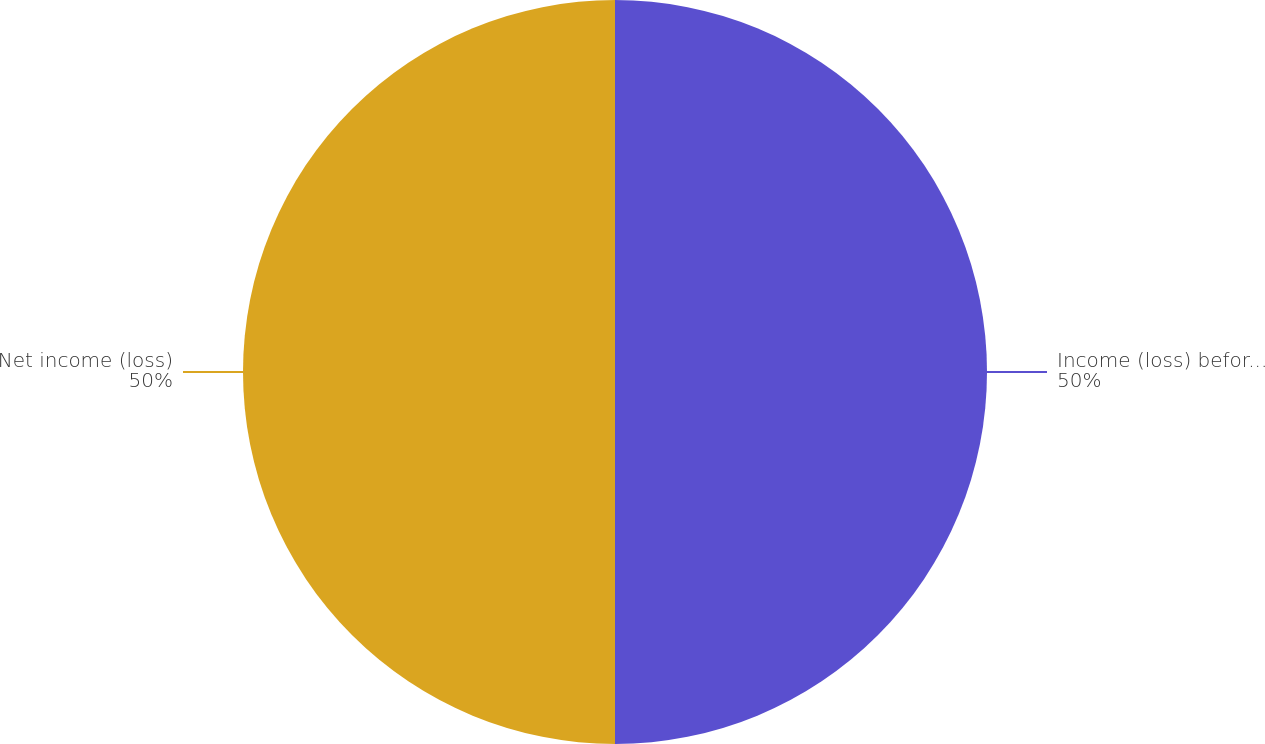<chart> <loc_0><loc_0><loc_500><loc_500><pie_chart><fcel>Income (loss) before income<fcel>Net income (loss)<nl><fcel>50.0%<fcel>50.0%<nl></chart> 